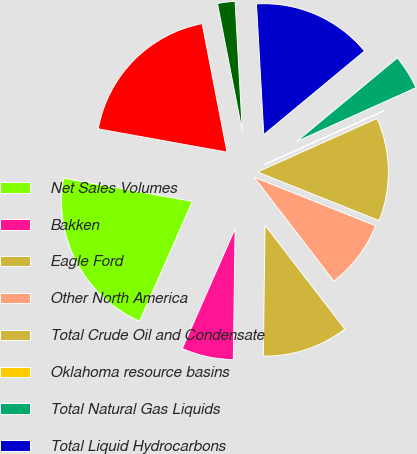<chart> <loc_0><loc_0><loc_500><loc_500><pie_chart><fcel>Net Sales Volumes<fcel>Bakken<fcel>Eagle Ford<fcel>Other North America<fcel>Total Crude Oil and Condensate<fcel>Oklahoma resource basins<fcel>Total Natural Gas Liquids<fcel>Total Liquid Hydrocarbons<fcel>Alaska<fcel>Total Natural Gas<nl><fcel>21.23%<fcel>6.4%<fcel>10.64%<fcel>8.52%<fcel>12.75%<fcel>0.04%<fcel>4.28%<fcel>14.87%<fcel>2.16%<fcel>19.11%<nl></chart> 